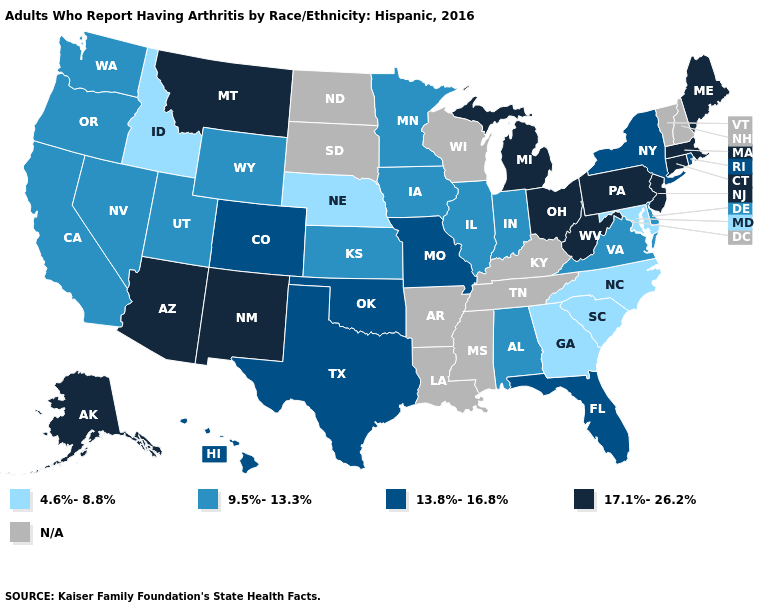What is the lowest value in the South?
Keep it brief. 4.6%-8.8%. Does the first symbol in the legend represent the smallest category?
Answer briefly. Yes. What is the value of North Carolina?
Give a very brief answer. 4.6%-8.8%. Name the states that have a value in the range 13.8%-16.8%?
Give a very brief answer. Colorado, Florida, Hawaii, Missouri, New York, Oklahoma, Rhode Island, Texas. Name the states that have a value in the range N/A?
Write a very short answer. Arkansas, Kentucky, Louisiana, Mississippi, New Hampshire, North Dakota, South Dakota, Tennessee, Vermont, Wisconsin. Name the states that have a value in the range N/A?
Quick response, please. Arkansas, Kentucky, Louisiana, Mississippi, New Hampshire, North Dakota, South Dakota, Tennessee, Vermont, Wisconsin. What is the value of Florida?
Short answer required. 13.8%-16.8%. Does Arizona have the highest value in the USA?
Concise answer only. Yes. What is the value of New Hampshire?
Keep it brief. N/A. Which states have the lowest value in the South?
Be succinct. Georgia, Maryland, North Carolina, South Carolina. Does Michigan have the highest value in the MidWest?
Write a very short answer. Yes. What is the value of Hawaii?
Be succinct. 13.8%-16.8%. What is the value of West Virginia?
Answer briefly. 17.1%-26.2%. 